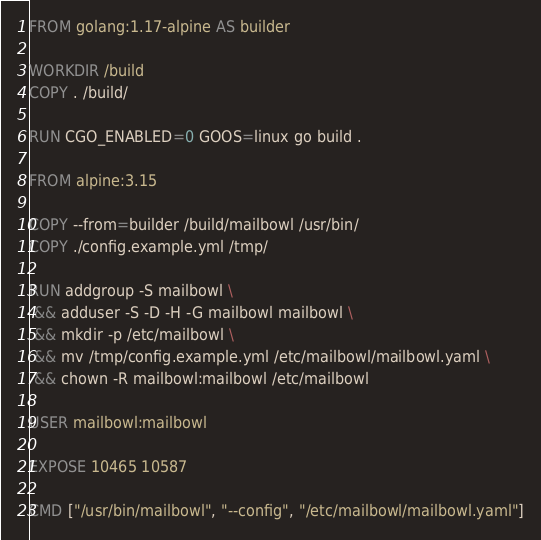<code> <loc_0><loc_0><loc_500><loc_500><_Dockerfile_>FROM golang:1.17-alpine AS builder

WORKDIR /build
COPY . /build/

RUN CGO_ENABLED=0 GOOS=linux go build .

FROM alpine:3.15

COPY --from=builder /build/mailbowl /usr/bin/
COPY ./config.example.yml /tmp/

RUN addgroup -S mailbowl \
 && adduser -S -D -H -G mailbowl mailbowl \
 && mkdir -p /etc/mailbowl \
 && mv /tmp/config.example.yml /etc/mailbowl/mailbowl.yaml \
 && chown -R mailbowl:mailbowl /etc/mailbowl

USER mailbowl:mailbowl

EXPOSE 10465 10587

CMD ["/usr/bin/mailbowl", "--config", "/etc/mailbowl/mailbowl.yaml"]
</code> 